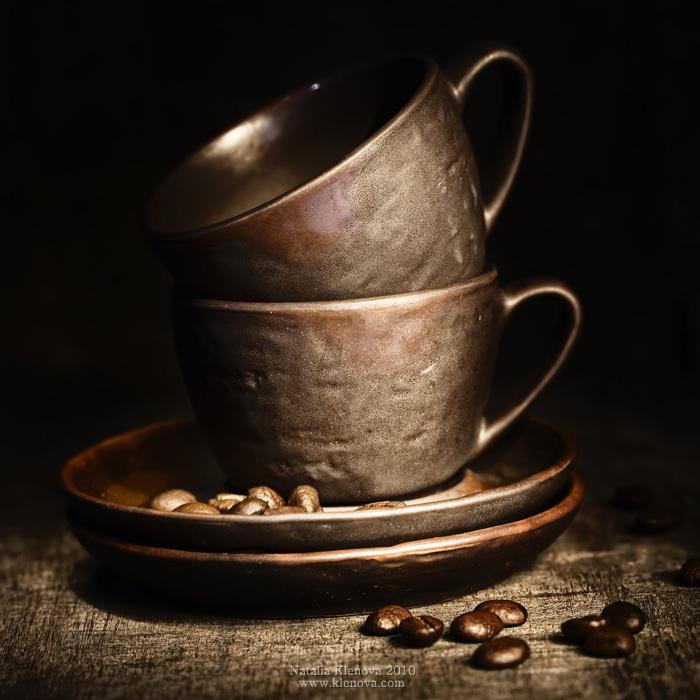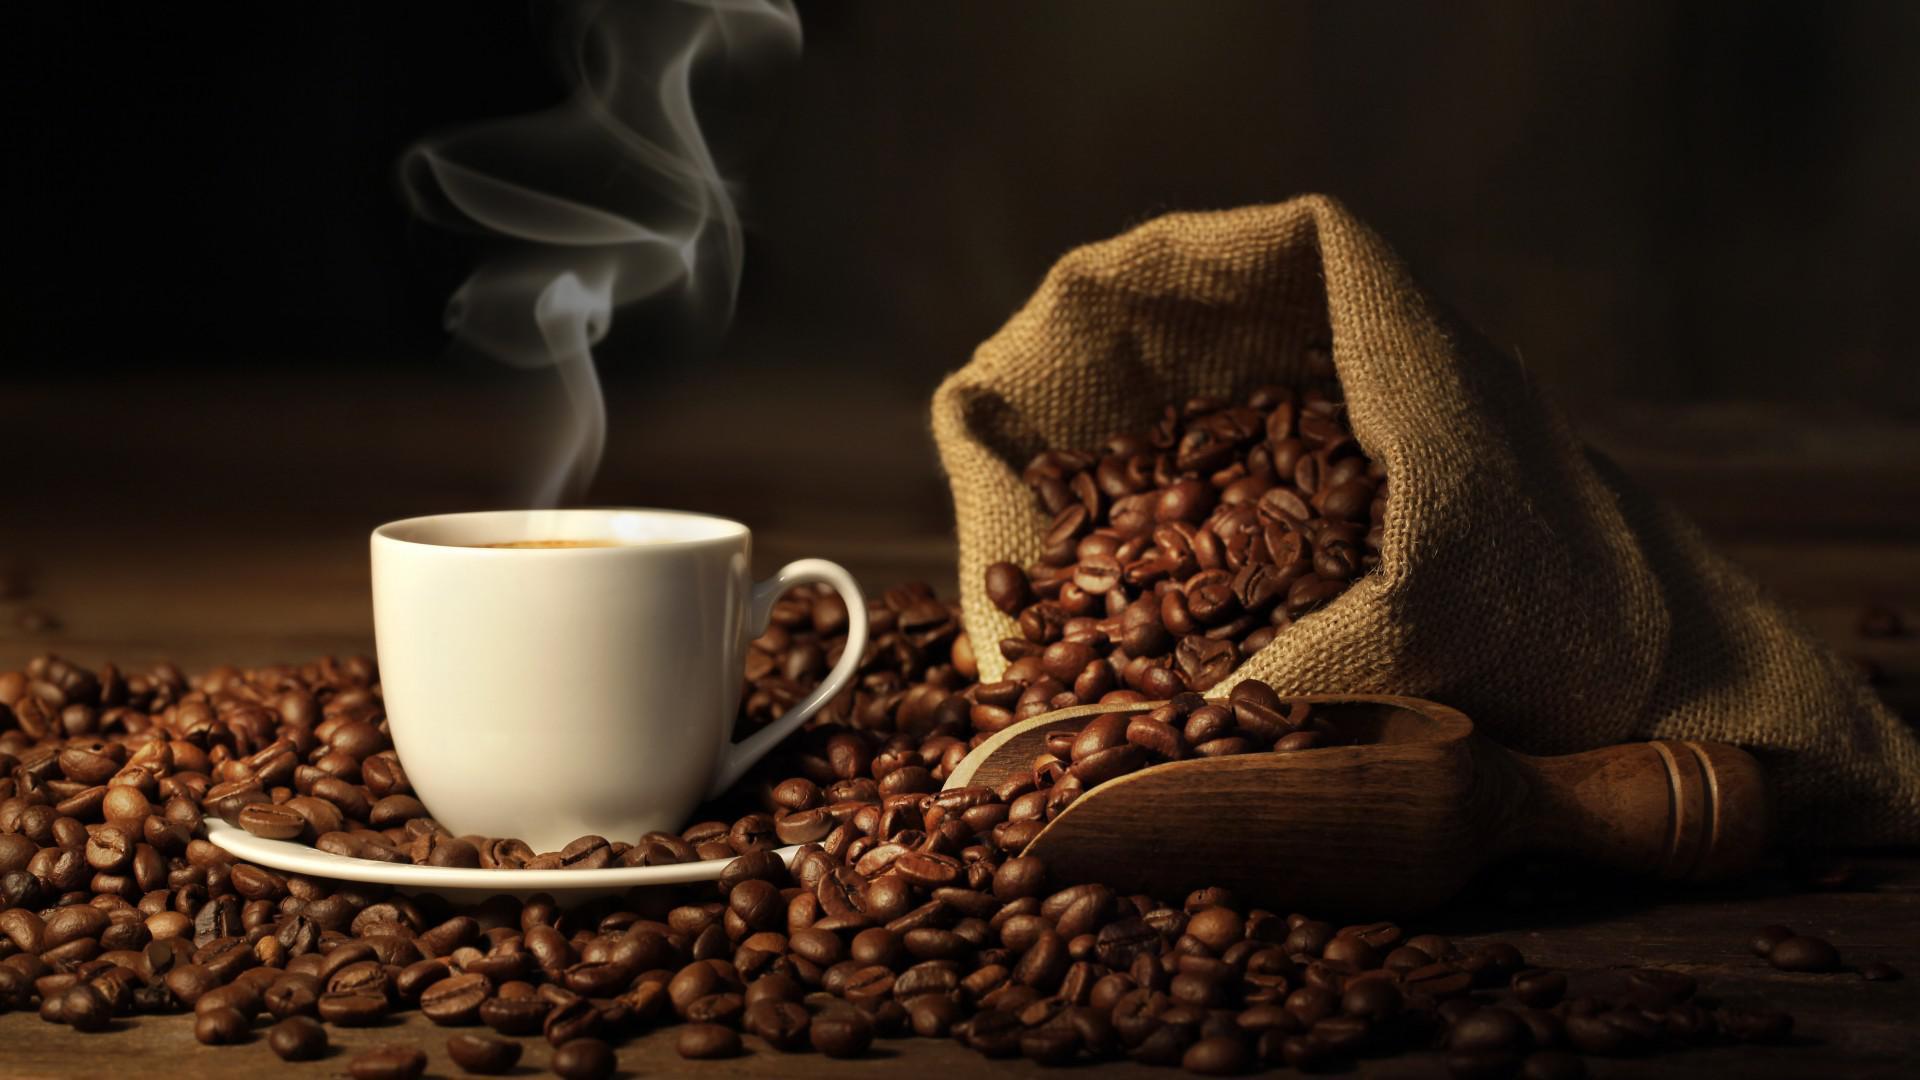The first image is the image on the left, the second image is the image on the right. Analyze the images presented: Is the assertion "Liquid is being poured into a cup in the left image of the pair." valid? Answer yes or no. No. The first image is the image on the left, the second image is the image on the right. For the images shown, is this caption "There are coffee beans in exactly one of the images." true? Answer yes or no. No. 